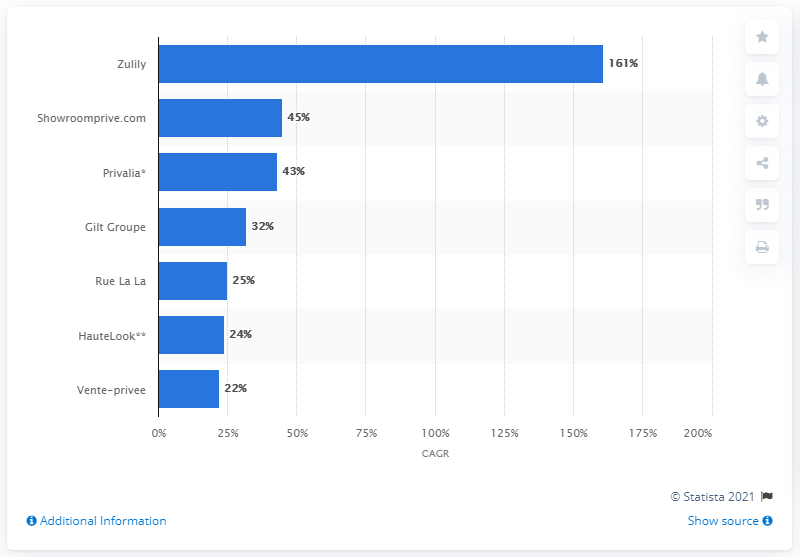Give some essential details in this illustration. During the survey period, Zulily was the flash sale site that experienced the fastest growth. 